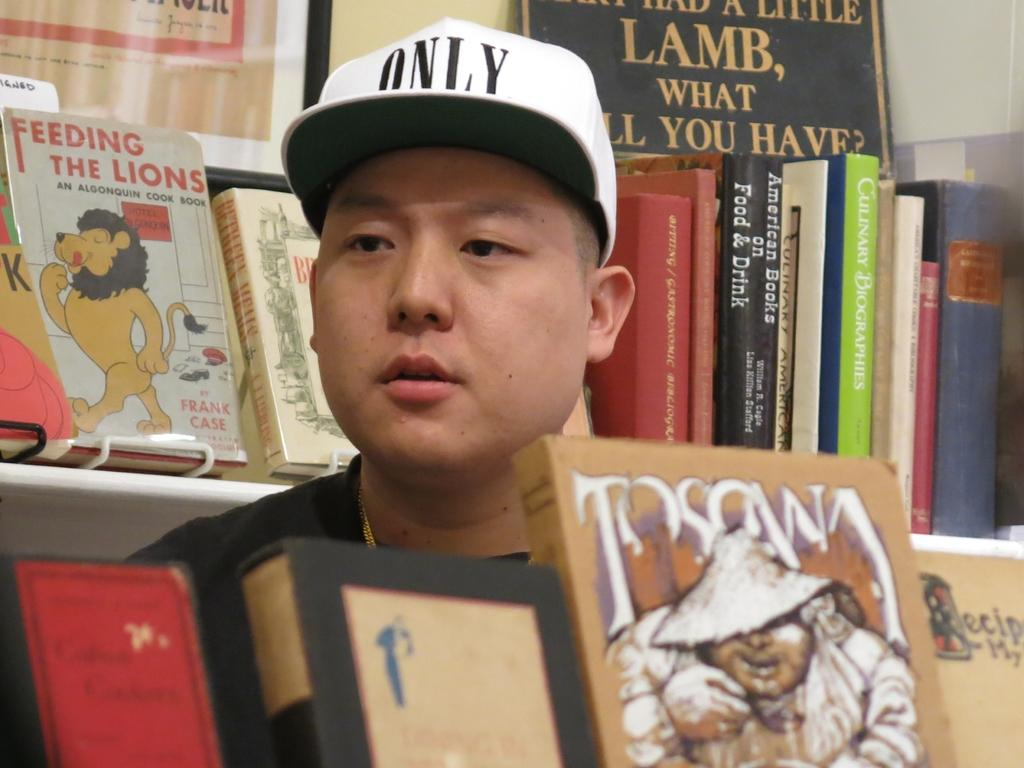<image>
Relay a brief, clear account of the picture shown. A man wearing an ONLY hat stands in front of a book called Feeding the Lions 